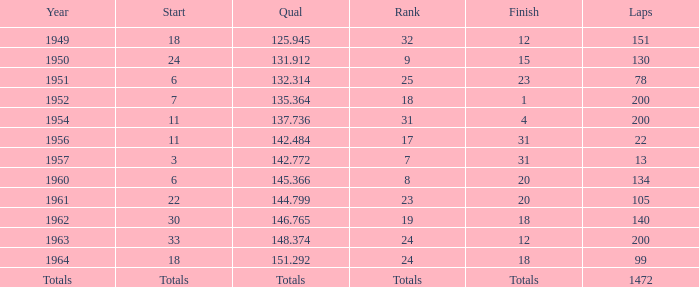Name the finish with Laps more than 200 Totals. Would you mind parsing the complete table? {'header': ['Year', 'Start', 'Qual', 'Rank', 'Finish', 'Laps'], 'rows': [['1949', '18', '125.945', '32', '12', '151'], ['1950', '24', '131.912', '9', '15', '130'], ['1951', '6', '132.314', '25', '23', '78'], ['1952', '7', '135.364', '18', '1', '200'], ['1954', '11', '137.736', '31', '4', '200'], ['1956', '11', '142.484', '17', '31', '22'], ['1957', '3', '142.772', '7', '31', '13'], ['1960', '6', '145.366', '8', '20', '134'], ['1961', '22', '144.799', '23', '20', '105'], ['1962', '30', '146.765', '19', '18', '140'], ['1963', '33', '148.374', '24', '12', '200'], ['1964', '18', '151.292', '24', '18', '99'], ['Totals', 'Totals', 'Totals', 'Totals', 'Totals', '1472']]} 